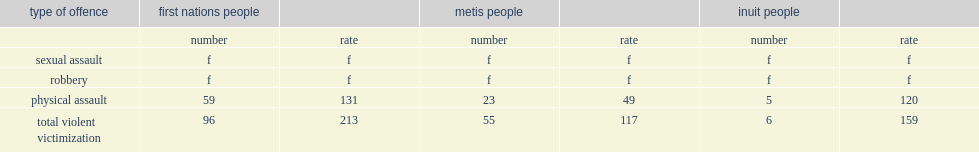Compared with the rest of the canadian population, how many incidents per 1,000 people did first nations people have a rate of violent victimization? 213.0. What was the rates of overall violence appeared to be higher for metis people when compared with the rest of canada, these differences were not found to be statistically significant? 117.0. What was the rates of overall violence appeared to be higher for inuit people when compared with the rest of canada, these differences were not found to be statistically significant? 159.0. Help me parse the entirety of this table. {'header': ['type of offence', 'first nations people', '', 'metis people', '', 'inuit people', ''], 'rows': [['', 'number', 'rate', 'number', 'rate', 'number', 'rate'], ['sexual assault', 'f', 'f', 'f', 'f', 'f', 'f'], ['robbery', 'f', 'f', 'f', 'f', 'f', 'f'], ['physical assault', '59', '131', '23', '49', '5', '120'], ['total violent victimization', '96', '213', '55', '117', '6', '159']]} 